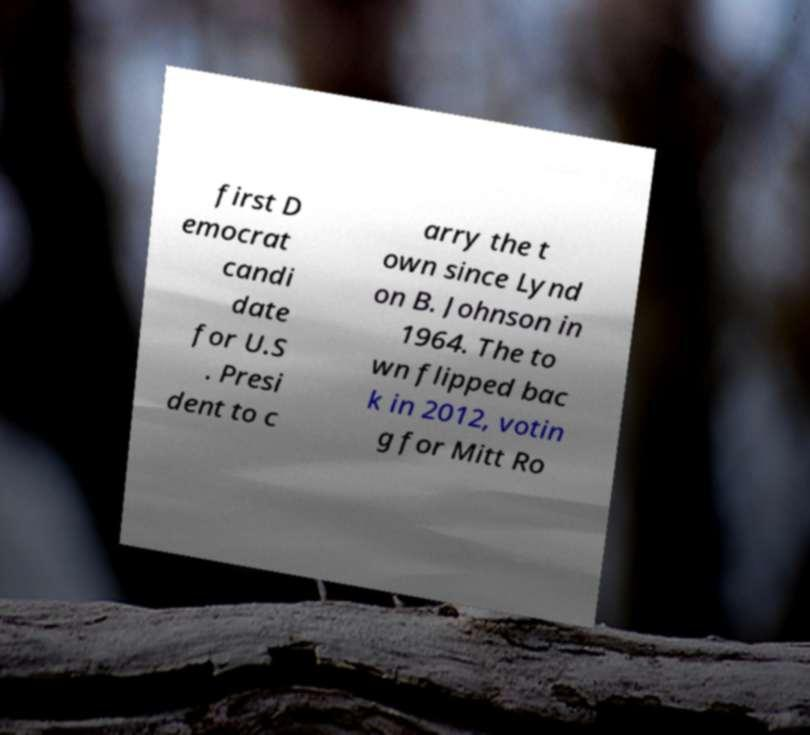Please identify and transcribe the text found in this image. first D emocrat candi date for U.S . Presi dent to c arry the t own since Lynd on B. Johnson in 1964. The to wn flipped bac k in 2012, votin g for Mitt Ro 